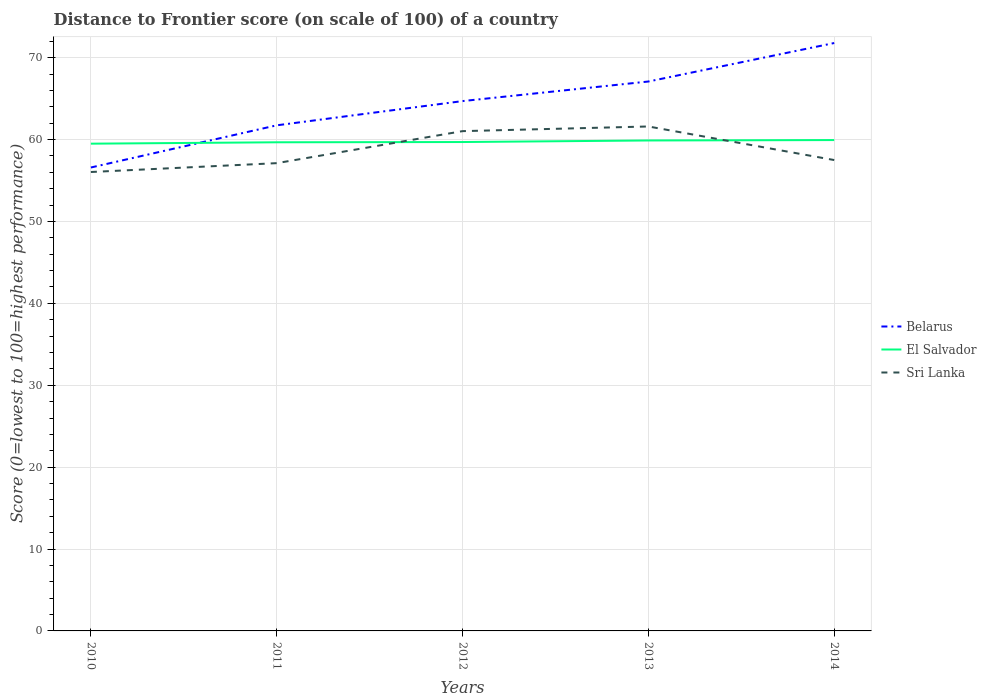How many different coloured lines are there?
Keep it short and to the point. 3. Does the line corresponding to El Salvador intersect with the line corresponding to Sri Lanka?
Your response must be concise. Yes. Across all years, what is the maximum distance to frontier score of in Sri Lanka?
Your answer should be very brief. 56.04. What is the total distance to frontier score of in Belarus in the graph?
Give a very brief answer. -8.11. What is the difference between the highest and the second highest distance to frontier score of in Sri Lanka?
Offer a terse response. 5.56. What is the difference between the highest and the lowest distance to frontier score of in El Salvador?
Make the answer very short. 2. What is the difference between two consecutive major ticks on the Y-axis?
Your answer should be very brief. 10. Does the graph contain grids?
Offer a very short reply. Yes. Where does the legend appear in the graph?
Your answer should be very brief. Center right. How many legend labels are there?
Keep it short and to the point. 3. What is the title of the graph?
Offer a terse response. Distance to Frontier score (on scale of 100) of a country. What is the label or title of the Y-axis?
Keep it short and to the point. Score (0=lowest to 100=highest performance). What is the Score (0=lowest to 100=highest performance) in Belarus in 2010?
Offer a very short reply. 56.59. What is the Score (0=lowest to 100=highest performance) in El Salvador in 2010?
Provide a succinct answer. 59.5. What is the Score (0=lowest to 100=highest performance) of Sri Lanka in 2010?
Give a very brief answer. 56.04. What is the Score (0=lowest to 100=highest performance) in Belarus in 2011?
Ensure brevity in your answer.  61.74. What is the Score (0=lowest to 100=highest performance) of El Salvador in 2011?
Offer a terse response. 59.67. What is the Score (0=lowest to 100=highest performance) of Sri Lanka in 2011?
Your answer should be very brief. 57.12. What is the Score (0=lowest to 100=highest performance) in Belarus in 2012?
Offer a terse response. 64.7. What is the Score (0=lowest to 100=highest performance) in El Salvador in 2012?
Keep it short and to the point. 59.7. What is the Score (0=lowest to 100=highest performance) of Sri Lanka in 2012?
Ensure brevity in your answer.  61.03. What is the Score (0=lowest to 100=highest performance) in Belarus in 2013?
Your answer should be very brief. 67.09. What is the Score (0=lowest to 100=highest performance) of El Salvador in 2013?
Your answer should be very brief. 59.89. What is the Score (0=lowest to 100=highest performance) in Sri Lanka in 2013?
Make the answer very short. 61.6. What is the Score (0=lowest to 100=highest performance) of Belarus in 2014?
Your answer should be very brief. 71.79. What is the Score (0=lowest to 100=highest performance) in El Salvador in 2014?
Provide a succinct answer. 59.94. What is the Score (0=lowest to 100=highest performance) in Sri Lanka in 2014?
Keep it short and to the point. 57.5. Across all years, what is the maximum Score (0=lowest to 100=highest performance) of Belarus?
Offer a terse response. 71.79. Across all years, what is the maximum Score (0=lowest to 100=highest performance) in El Salvador?
Offer a very short reply. 59.94. Across all years, what is the maximum Score (0=lowest to 100=highest performance) of Sri Lanka?
Give a very brief answer. 61.6. Across all years, what is the minimum Score (0=lowest to 100=highest performance) of Belarus?
Offer a very short reply. 56.59. Across all years, what is the minimum Score (0=lowest to 100=highest performance) in El Salvador?
Ensure brevity in your answer.  59.5. Across all years, what is the minimum Score (0=lowest to 100=highest performance) of Sri Lanka?
Your answer should be very brief. 56.04. What is the total Score (0=lowest to 100=highest performance) of Belarus in the graph?
Keep it short and to the point. 321.91. What is the total Score (0=lowest to 100=highest performance) of El Salvador in the graph?
Make the answer very short. 298.7. What is the total Score (0=lowest to 100=highest performance) in Sri Lanka in the graph?
Ensure brevity in your answer.  293.29. What is the difference between the Score (0=lowest to 100=highest performance) in Belarus in 2010 and that in 2011?
Offer a terse response. -5.15. What is the difference between the Score (0=lowest to 100=highest performance) of El Salvador in 2010 and that in 2011?
Your answer should be very brief. -0.17. What is the difference between the Score (0=lowest to 100=highest performance) in Sri Lanka in 2010 and that in 2011?
Give a very brief answer. -1.08. What is the difference between the Score (0=lowest to 100=highest performance) in Belarus in 2010 and that in 2012?
Ensure brevity in your answer.  -8.11. What is the difference between the Score (0=lowest to 100=highest performance) in Sri Lanka in 2010 and that in 2012?
Your answer should be compact. -4.99. What is the difference between the Score (0=lowest to 100=highest performance) in Belarus in 2010 and that in 2013?
Give a very brief answer. -10.5. What is the difference between the Score (0=lowest to 100=highest performance) in El Salvador in 2010 and that in 2013?
Offer a terse response. -0.39. What is the difference between the Score (0=lowest to 100=highest performance) in Sri Lanka in 2010 and that in 2013?
Provide a succinct answer. -5.56. What is the difference between the Score (0=lowest to 100=highest performance) of Belarus in 2010 and that in 2014?
Ensure brevity in your answer.  -15.2. What is the difference between the Score (0=lowest to 100=highest performance) of El Salvador in 2010 and that in 2014?
Keep it short and to the point. -0.44. What is the difference between the Score (0=lowest to 100=highest performance) of Sri Lanka in 2010 and that in 2014?
Ensure brevity in your answer.  -1.46. What is the difference between the Score (0=lowest to 100=highest performance) of Belarus in 2011 and that in 2012?
Your answer should be compact. -2.96. What is the difference between the Score (0=lowest to 100=highest performance) of El Salvador in 2011 and that in 2012?
Keep it short and to the point. -0.03. What is the difference between the Score (0=lowest to 100=highest performance) in Sri Lanka in 2011 and that in 2012?
Give a very brief answer. -3.91. What is the difference between the Score (0=lowest to 100=highest performance) in Belarus in 2011 and that in 2013?
Give a very brief answer. -5.35. What is the difference between the Score (0=lowest to 100=highest performance) of El Salvador in 2011 and that in 2013?
Your answer should be very brief. -0.22. What is the difference between the Score (0=lowest to 100=highest performance) of Sri Lanka in 2011 and that in 2013?
Offer a very short reply. -4.48. What is the difference between the Score (0=lowest to 100=highest performance) of Belarus in 2011 and that in 2014?
Provide a short and direct response. -10.05. What is the difference between the Score (0=lowest to 100=highest performance) in El Salvador in 2011 and that in 2014?
Your response must be concise. -0.27. What is the difference between the Score (0=lowest to 100=highest performance) of Sri Lanka in 2011 and that in 2014?
Provide a short and direct response. -0.38. What is the difference between the Score (0=lowest to 100=highest performance) of Belarus in 2012 and that in 2013?
Give a very brief answer. -2.39. What is the difference between the Score (0=lowest to 100=highest performance) in El Salvador in 2012 and that in 2013?
Ensure brevity in your answer.  -0.19. What is the difference between the Score (0=lowest to 100=highest performance) of Sri Lanka in 2012 and that in 2013?
Keep it short and to the point. -0.57. What is the difference between the Score (0=lowest to 100=highest performance) in Belarus in 2012 and that in 2014?
Provide a succinct answer. -7.09. What is the difference between the Score (0=lowest to 100=highest performance) of El Salvador in 2012 and that in 2014?
Provide a succinct answer. -0.24. What is the difference between the Score (0=lowest to 100=highest performance) of Sri Lanka in 2012 and that in 2014?
Keep it short and to the point. 3.53. What is the difference between the Score (0=lowest to 100=highest performance) of Sri Lanka in 2013 and that in 2014?
Your answer should be compact. 4.1. What is the difference between the Score (0=lowest to 100=highest performance) of Belarus in 2010 and the Score (0=lowest to 100=highest performance) of El Salvador in 2011?
Your answer should be compact. -3.08. What is the difference between the Score (0=lowest to 100=highest performance) in Belarus in 2010 and the Score (0=lowest to 100=highest performance) in Sri Lanka in 2011?
Your answer should be compact. -0.53. What is the difference between the Score (0=lowest to 100=highest performance) of El Salvador in 2010 and the Score (0=lowest to 100=highest performance) of Sri Lanka in 2011?
Offer a very short reply. 2.38. What is the difference between the Score (0=lowest to 100=highest performance) in Belarus in 2010 and the Score (0=lowest to 100=highest performance) in El Salvador in 2012?
Offer a very short reply. -3.11. What is the difference between the Score (0=lowest to 100=highest performance) in Belarus in 2010 and the Score (0=lowest to 100=highest performance) in Sri Lanka in 2012?
Your answer should be very brief. -4.44. What is the difference between the Score (0=lowest to 100=highest performance) in El Salvador in 2010 and the Score (0=lowest to 100=highest performance) in Sri Lanka in 2012?
Your answer should be compact. -1.53. What is the difference between the Score (0=lowest to 100=highest performance) in Belarus in 2010 and the Score (0=lowest to 100=highest performance) in El Salvador in 2013?
Provide a succinct answer. -3.3. What is the difference between the Score (0=lowest to 100=highest performance) in Belarus in 2010 and the Score (0=lowest to 100=highest performance) in Sri Lanka in 2013?
Keep it short and to the point. -5.01. What is the difference between the Score (0=lowest to 100=highest performance) in El Salvador in 2010 and the Score (0=lowest to 100=highest performance) in Sri Lanka in 2013?
Keep it short and to the point. -2.1. What is the difference between the Score (0=lowest to 100=highest performance) of Belarus in 2010 and the Score (0=lowest to 100=highest performance) of El Salvador in 2014?
Your answer should be compact. -3.35. What is the difference between the Score (0=lowest to 100=highest performance) in Belarus in 2010 and the Score (0=lowest to 100=highest performance) in Sri Lanka in 2014?
Your response must be concise. -0.91. What is the difference between the Score (0=lowest to 100=highest performance) of Belarus in 2011 and the Score (0=lowest to 100=highest performance) of El Salvador in 2012?
Your response must be concise. 2.04. What is the difference between the Score (0=lowest to 100=highest performance) in Belarus in 2011 and the Score (0=lowest to 100=highest performance) in Sri Lanka in 2012?
Offer a very short reply. 0.71. What is the difference between the Score (0=lowest to 100=highest performance) in El Salvador in 2011 and the Score (0=lowest to 100=highest performance) in Sri Lanka in 2012?
Provide a succinct answer. -1.36. What is the difference between the Score (0=lowest to 100=highest performance) in Belarus in 2011 and the Score (0=lowest to 100=highest performance) in El Salvador in 2013?
Make the answer very short. 1.85. What is the difference between the Score (0=lowest to 100=highest performance) of Belarus in 2011 and the Score (0=lowest to 100=highest performance) of Sri Lanka in 2013?
Ensure brevity in your answer.  0.14. What is the difference between the Score (0=lowest to 100=highest performance) of El Salvador in 2011 and the Score (0=lowest to 100=highest performance) of Sri Lanka in 2013?
Ensure brevity in your answer.  -1.93. What is the difference between the Score (0=lowest to 100=highest performance) in Belarus in 2011 and the Score (0=lowest to 100=highest performance) in El Salvador in 2014?
Your answer should be compact. 1.8. What is the difference between the Score (0=lowest to 100=highest performance) in Belarus in 2011 and the Score (0=lowest to 100=highest performance) in Sri Lanka in 2014?
Give a very brief answer. 4.24. What is the difference between the Score (0=lowest to 100=highest performance) of El Salvador in 2011 and the Score (0=lowest to 100=highest performance) of Sri Lanka in 2014?
Give a very brief answer. 2.17. What is the difference between the Score (0=lowest to 100=highest performance) of Belarus in 2012 and the Score (0=lowest to 100=highest performance) of El Salvador in 2013?
Your answer should be very brief. 4.81. What is the difference between the Score (0=lowest to 100=highest performance) in Belarus in 2012 and the Score (0=lowest to 100=highest performance) in El Salvador in 2014?
Your answer should be very brief. 4.76. What is the difference between the Score (0=lowest to 100=highest performance) of Belarus in 2012 and the Score (0=lowest to 100=highest performance) of Sri Lanka in 2014?
Give a very brief answer. 7.2. What is the difference between the Score (0=lowest to 100=highest performance) in El Salvador in 2012 and the Score (0=lowest to 100=highest performance) in Sri Lanka in 2014?
Provide a succinct answer. 2.2. What is the difference between the Score (0=lowest to 100=highest performance) of Belarus in 2013 and the Score (0=lowest to 100=highest performance) of El Salvador in 2014?
Keep it short and to the point. 7.15. What is the difference between the Score (0=lowest to 100=highest performance) in Belarus in 2013 and the Score (0=lowest to 100=highest performance) in Sri Lanka in 2014?
Provide a succinct answer. 9.59. What is the difference between the Score (0=lowest to 100=highest performance) of El Salvador in 2013 and the Score (0=lowest to 100=highest performance) of Sri Lanka in 2014?
Give a very brief answer. 2.39. What is the average Score (0=lowest to 100=highest performance) of Belarus per year?
Ensure brevity in your answer.  64.38. What is the average Score (0=lowest to 100=highest performance) in El Salvador per year?
Ensure brevity in your answer.  59.74. What is the average Score (0=lowest to 100=highest performance) in Sri Lanka per year?
Your answer should be very brief. 58.66. In the year 2010, what is the difference between the Score (0=lowest to 100=highest performance) of Belarus and Score (0=lowest to 100=highest performance) of El Salvador?
Your answer should be very brief. -2.91. In the year 2010, what is the difference between the Score (0=lowest to 100=highest performance) of Belarus and Score (0=lowest to 100=highest performance) of Sri Lanka?
Provide a succinct answer. 0.55. In the year 2010, what is the difference between the Score (0=lowest to 100=highest performance) in El Salvador and Score (0=lowest to 100=highest performance) in Sri Lanka?
Keep it short and to the point. 3.46. In the year 2011, what is the difference between the Score (0=lowest to 100=highest performance) in Belarus and Score (0=lowest to 100=highest performance) in El Salvador?
Provide a succinct answer. 2.07. In the year 2011, what is the difference between the Score (0=lowest to 100=highest performance) of Belarus and Score (0=lowest to 100=highest performance) of Sri Lanka?
Make the answer very short. 4.62. In the year 2011, what is the difference between the Score (0=lowest to 100=highest performance) in El Salvador and Score (0=lowest to 100=highest performance) in Sri Lanka?
Offer a terse response. 2.55. In the year 2012, what is the difference between the Score (0=lowest to 100=highest performance) in Belarus and Score (0=lowest to 100=highest performance) in Sri Lanka?
Provide a succinct answer. 3.67. In the year 2012, what is the difference between the Score (0=lowest to 100=highest performance) of El Salvador and Score (0=lowest to 100=highest performance) of Sri Lanka?
Offer a very short reply. -1.33. In the year 2013, what is the difference between the Score (0=lowest to 100=highest performance) in Belarus and Score (0=lowest to 100=highest performance) in El Salvador?
Give a very brief answer. 7.2. In the year 2013, what is the difference between the Score (0=lowest to 100=highest performance) of Belarus and Score (0=lowest to 100=highest performance) of Sri Lanka?
Your response must be concise. 5.49. In the year 2013, what is the difference between the Score (0=lowest to 100=highest performance) of El Salvador and Score (0=lowest to 100=highest performance) of Sri Lanka?
Ensure brevity in your answer.  -1.71. In the year 2014, what is the difference between the Score (0=lowest to 100=highest performance) of Belarus and Score (0=lowest to 100=highest performance) of El Salvador?
Make the answer very short. 11.85. In the year 2014, what is the difference between the Score (0=lowest to 100=highest performance) in Belarus and Score (0=lowest to 100=highest performance) in Sri Lanka?
Give a very brief answer. 14.29. In the year 2014, what is the difference between the Score (0=lowest to 100=highest performance) of El Salvador and Score (0=lowest to 100=highest performance) of Sri Lanka?
Provide a short and direct response. 2.44. What is the ratio of the Score (0=lowest to 100=highest performance) of Belarus in 2010 to that in 2011?
Give a very brief answer. 0.92. What is the ratio of the Score (0=lowest to 100=highest performance) in El Salvador in 2010 to that in 2011?
Your response must be concise. 1. What is the ratio of the Score (0=lowest to 100=highest performance) of Sri Lanka in 2010 to that in 2011?
Provide a succinct answer. 0.98. What is the ratio of the Score (0=lowest to 100=highest performance) of Belarus in 2010 to that in 2012?
Your response must be concise. 0.87. What is the ratio of the Score (0=lowest to 100=highest performance) in Sri Lanka in 2010 to that in 2012?
Make the answer very short. 0.92. What is the ratio of the Score (0=lowest to 100=highest performance) in Belarus in 2010 to that in 2013?
Give a very brief answer. 0.84. What is the ratio of the Score (0=lowest to 100=highest performance) in El Salvador in 2010 to that in 2013?
Ensure brevity in your answer.  0.99. What is the ratio of the Score (0=lowest to 100=highest performance) in Sri Lanka in 2010 to that in 2013?
Ensure brevity in your answer.  0.91. What is the ratio of the Score (0=lowest to 100=highest performance) in Belarus in 2010 to that in 2014?
Offer a terse response. 0.79. What is the ratio of the Score (0=lowest to 100=highest performance) in Sri Lanka in 2010 to that in 2014?
Provide a succinct answer. 0.97. What is the ratio of the Score (0=lowest to 100=highest performance) in Belarus in 2011 to that in 2012?
Give a very brief answer. 0.95. What is the ratio of the Score (0=lowest to 100=highest performance) of El Salvador in 2011 to that in 2012?
Offer a very short reply. 1. What is the ratio of the Score (0=lowest to 100=highest performance) in Sri Lanka in 2011 to that in 2012?
Give a very brief answer. 0.94. What is the ratio of the Score (0=lowest to 100=highest performance) of Belarus in 2011 to that in 2013?
Your response must be concise. 0.92. What is the ratio of the Score (0=lowest to 100=highest performance) in El Salvador in 2011 to that in 2013?
Ensure brevity in your answer.  1. What is the ratio of the Score (0=lowest to 100=highest performance) in Sri Lanka in 2011 to that in 2013?
Make the answer very short. 0.93. What is the ratio of the Score (0=lowest to 100=highest performance) in Belarus in 2011 to that in 2014?
Make the answer very short. 0.86. What is the ratio of the Score (0=lowest to 100=highest performance) in Sri Lanka in 2011 to that in 2014?
Offer a very short reply. 0.99. What is the ratio of the Score (0=lowest to 100=highest performance) in Belarus in 2012 to that in 2013?
Give a very brief answer. 0.96. What is the ratio of the Score (0=lowest to 100=highest performance) of El Salvador in 2012 to that in 2013?
Ensure brevity in your answer.  1. What is the ratio of the Score (0=lowest to 100=highest performance) in Sri Lanka in 2012 to that in 2013?
Provide a succinct answer. 0.99. What is the ratio of the Score (0=lowest to 100=highest performance) of Belarus in 2012 to that in 2014?
Your answer should be very brief. 0.9. What is the ratio of the Score (0=lowest to 100=highest performance) of Sri Lanka in 2012 to that in 2014?
Your answer should be very brief. 1.06. What is the ratio of the Score (0=lowest to 100=highest performance) of Belarus in 2013 to that in 2014?
Make the answer very short. 0.93. What is the ratio of the Score (0=lowest to 100=highest performance) in El Salvador in 2013 to that in 2014?
Ensure brevity in your answer.  1. What is the ratio of the Score (0=lowest to 100=highest performance) of Sri Lanka in 2013 to that in 2014?
Provide a succinct answer. 1.07. What is the difference between the highest and the second highest Score (0=lowest to 100=highest performance) of Sri Lanka?
Ensure brevity in your answer.  0.57. What is the difference between the highest and the lowest Score (0=lowest to 100=highest performance) of Belarus?
Provide a succinct answer. 15.2. What is the difference between the highest and the lowest Score (0=lowest to 100=highest performance) of El Salvador?
Give a very brief answer. 0.44. What is the difference between the highest and the lowest Score (0=lowest to 100=highest performance) of Sri Lanka?
Your answer should be compact. 5.56. 